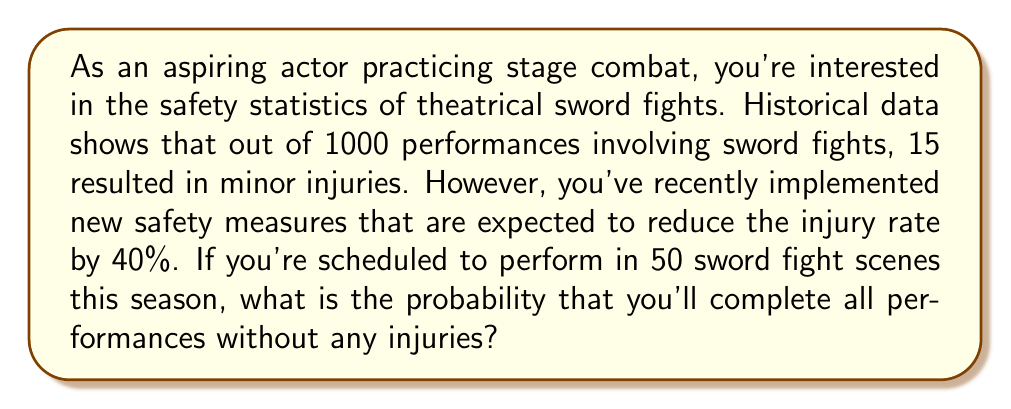Could you help me with this problem? Let's approach this problem step-by-step using Bayesian statistics:

1) First, let's calculate the original probability of injury per performance:
   $P(\text{injury}) = \frac{15}{1000} = 0.015$ or 1.5%

2) With the new safety measures, the injury rate is expected to reduce by 40%:
   $P(\text{injury with new measures}) = 0.015 \times (1 - 0.4) = 0.009$ or 0.9%

3) Therefore, the probability of no injury in a single performance is:
   $P(\text{no injury}) = 1 - 0.009 = 0.991$ or 99.1%

4) Now, we need to calculate the probability of no injuries in all 50 performances. This is a binomial probability problem where we want all successes (no injuries).

5) The probability of all successes in n trials is given by:
   $P(\text{all successes}) = p^n$
   where $p$ is the probability of success in a single trial and $n$ is the number of trials.

6) In our case:
   $p = 0.991$ (probability of no injury in a single performance)
   $n = 50$ (number of performances)

7) Therefore, the probability of no injuries in all 50 performances is:
   $P(\text{no injuries in 50 performances}) = 0.991^{50}$

8) Using a calculator (as this is a complex calculation):
   $0.991^{50} \approx 0.6376$ or about 63.76%
Answer: The probability of completing all 50 sword fight scenes without any injuries is approximately 0.6376 or 63.76%. 